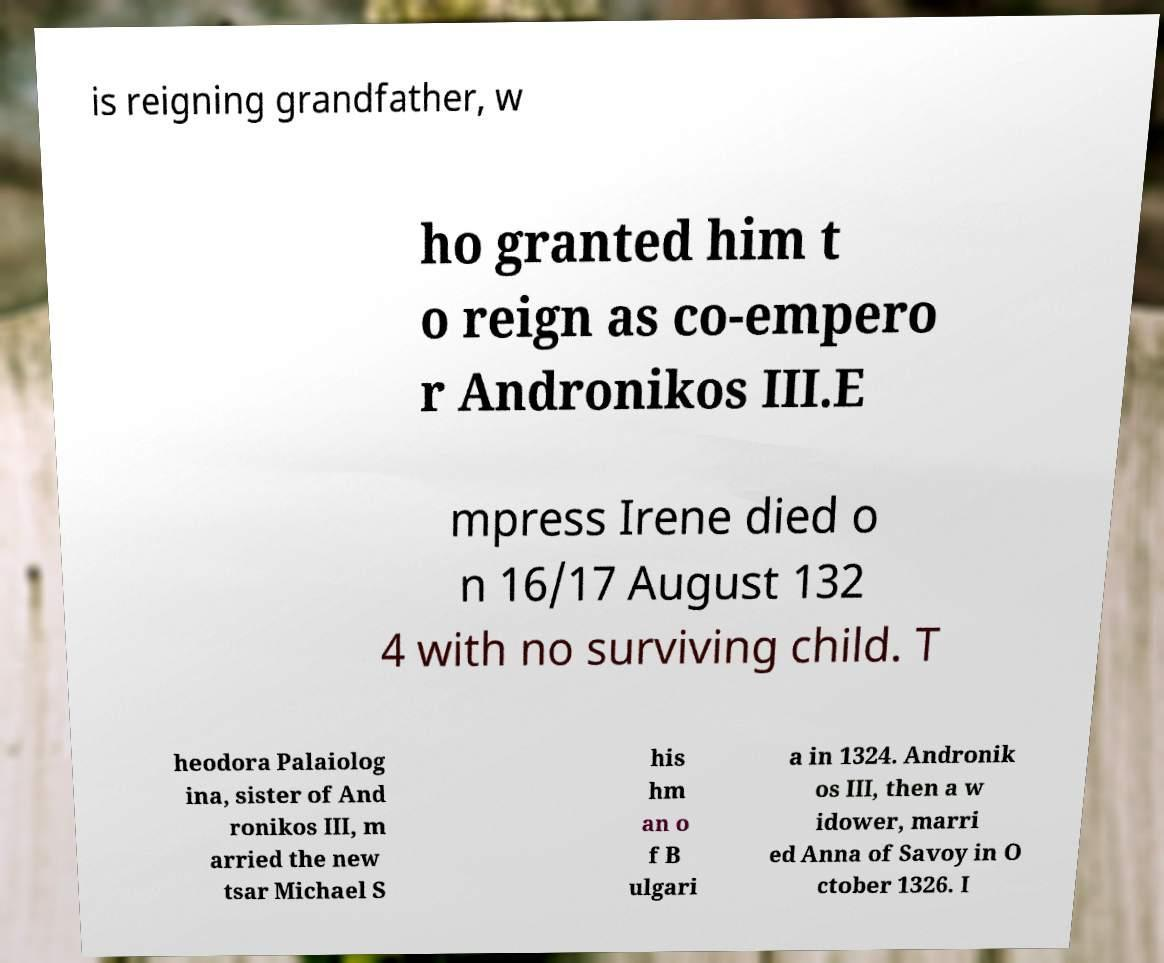What messages or text are displayed in this image? I need them in a readable, typed format. is reigning grandfather, w ho granted him t o reign as co-empero r Andronikos III.E mpress Irene died o n 16/17 August 132 4 with no surviving child. T heodora Palaiolog ina, sister of And ronikos III, m arried the new tsar Michael S his hm an o f B ulgari a in 1324. Andronik os III, then a w idower, marri ed Anna of Savoy in O ctober 1326. I 